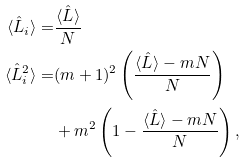Convert formula to latex. <formula><loc_0><loc_0><loc_500><loc_500>\langle \hat { L } _ { i } \rangle = & \frac { \langle \hat { L } \rangle } { N } \\ \langle \hat { L } _ { i } ^ { 2 } \rangle = & ( m + 1 ) ^ { 2 } \left ( \frac { \langle \hat { L } \rangle - m N } { N } \right ) \\ & + m ^ { 2 } \left ( 1 - \frac { \langle \hat { L } \rangle - m N } { N } \right ) ,</formula> 